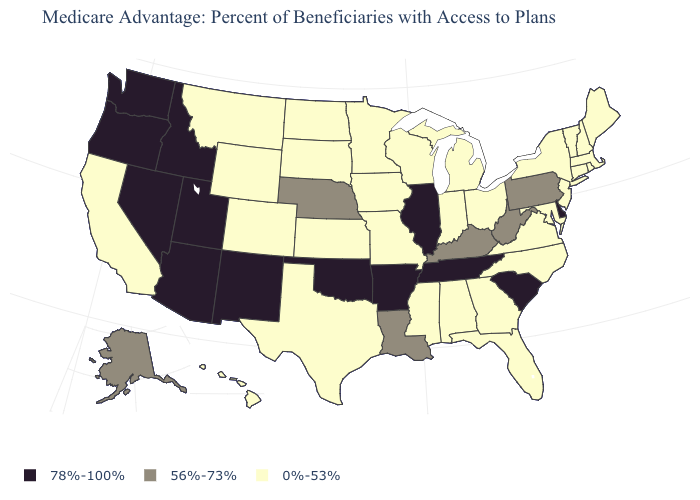Does Vermont have the lowest value in the USA?
Quick response, please. Yes. What is the value of Mississippi?
Quick response, please. 0%-53%. Among the states that border New York , which have the highest value?
Concise answer only. Pennsylvania. Which states hav the highest value in the South?
Be succinct. Arkansas, Delaware, Oklahoma, South Carolina, Tennessee. How many symbols are there in the legend?
Short answer required. 3. What is the highest value in the USA?
Give a very brief answer. 78%-100%. What is the value of New Mexico?
Answer briefly. 78%-100%. What is the lowest value in the Northeast?
Write a very short answer. 0%-53%. What is the lowest value in states that border Kentucky?
Concise answer only. 0%-53%. Among the states that border Missouri , which have the lowest value?
Concise answer only. Iowa, Kansas. Name the states that have a value in the range 0%-53%?
Short answer required. Alabama, California, Colorado, Connecticut, Florida, Georgia, Hawaii, Iowa, Indiana, Kansas, Massachusetts, Maryland, Maine, Michigan, Minnesota, Missouri, Mississippi, Montana, North Carolina, North Dakota, New Hampshire, New Jersey, New York, Ohio, Rhode Island, South Dakota, Texas, Virginia, Vermont, Wisconsin, Wyoming. What is the value of Vermont?
Give a very brief answer. 0%-53%. What is the highest value in states that border Virginia?
Write a very short answer. 78%-100%. Name the states that have a value in the range 78%-100%?
Be succinct. Arkansas, Arizona, Delaware, Idaho, Illinois, New Mexico, Nevada, Oklahoma, Oregon, South Carolina, Tennessee, Utah, Washington. Is the legend a continuous bar?
Concise answer only. No. 